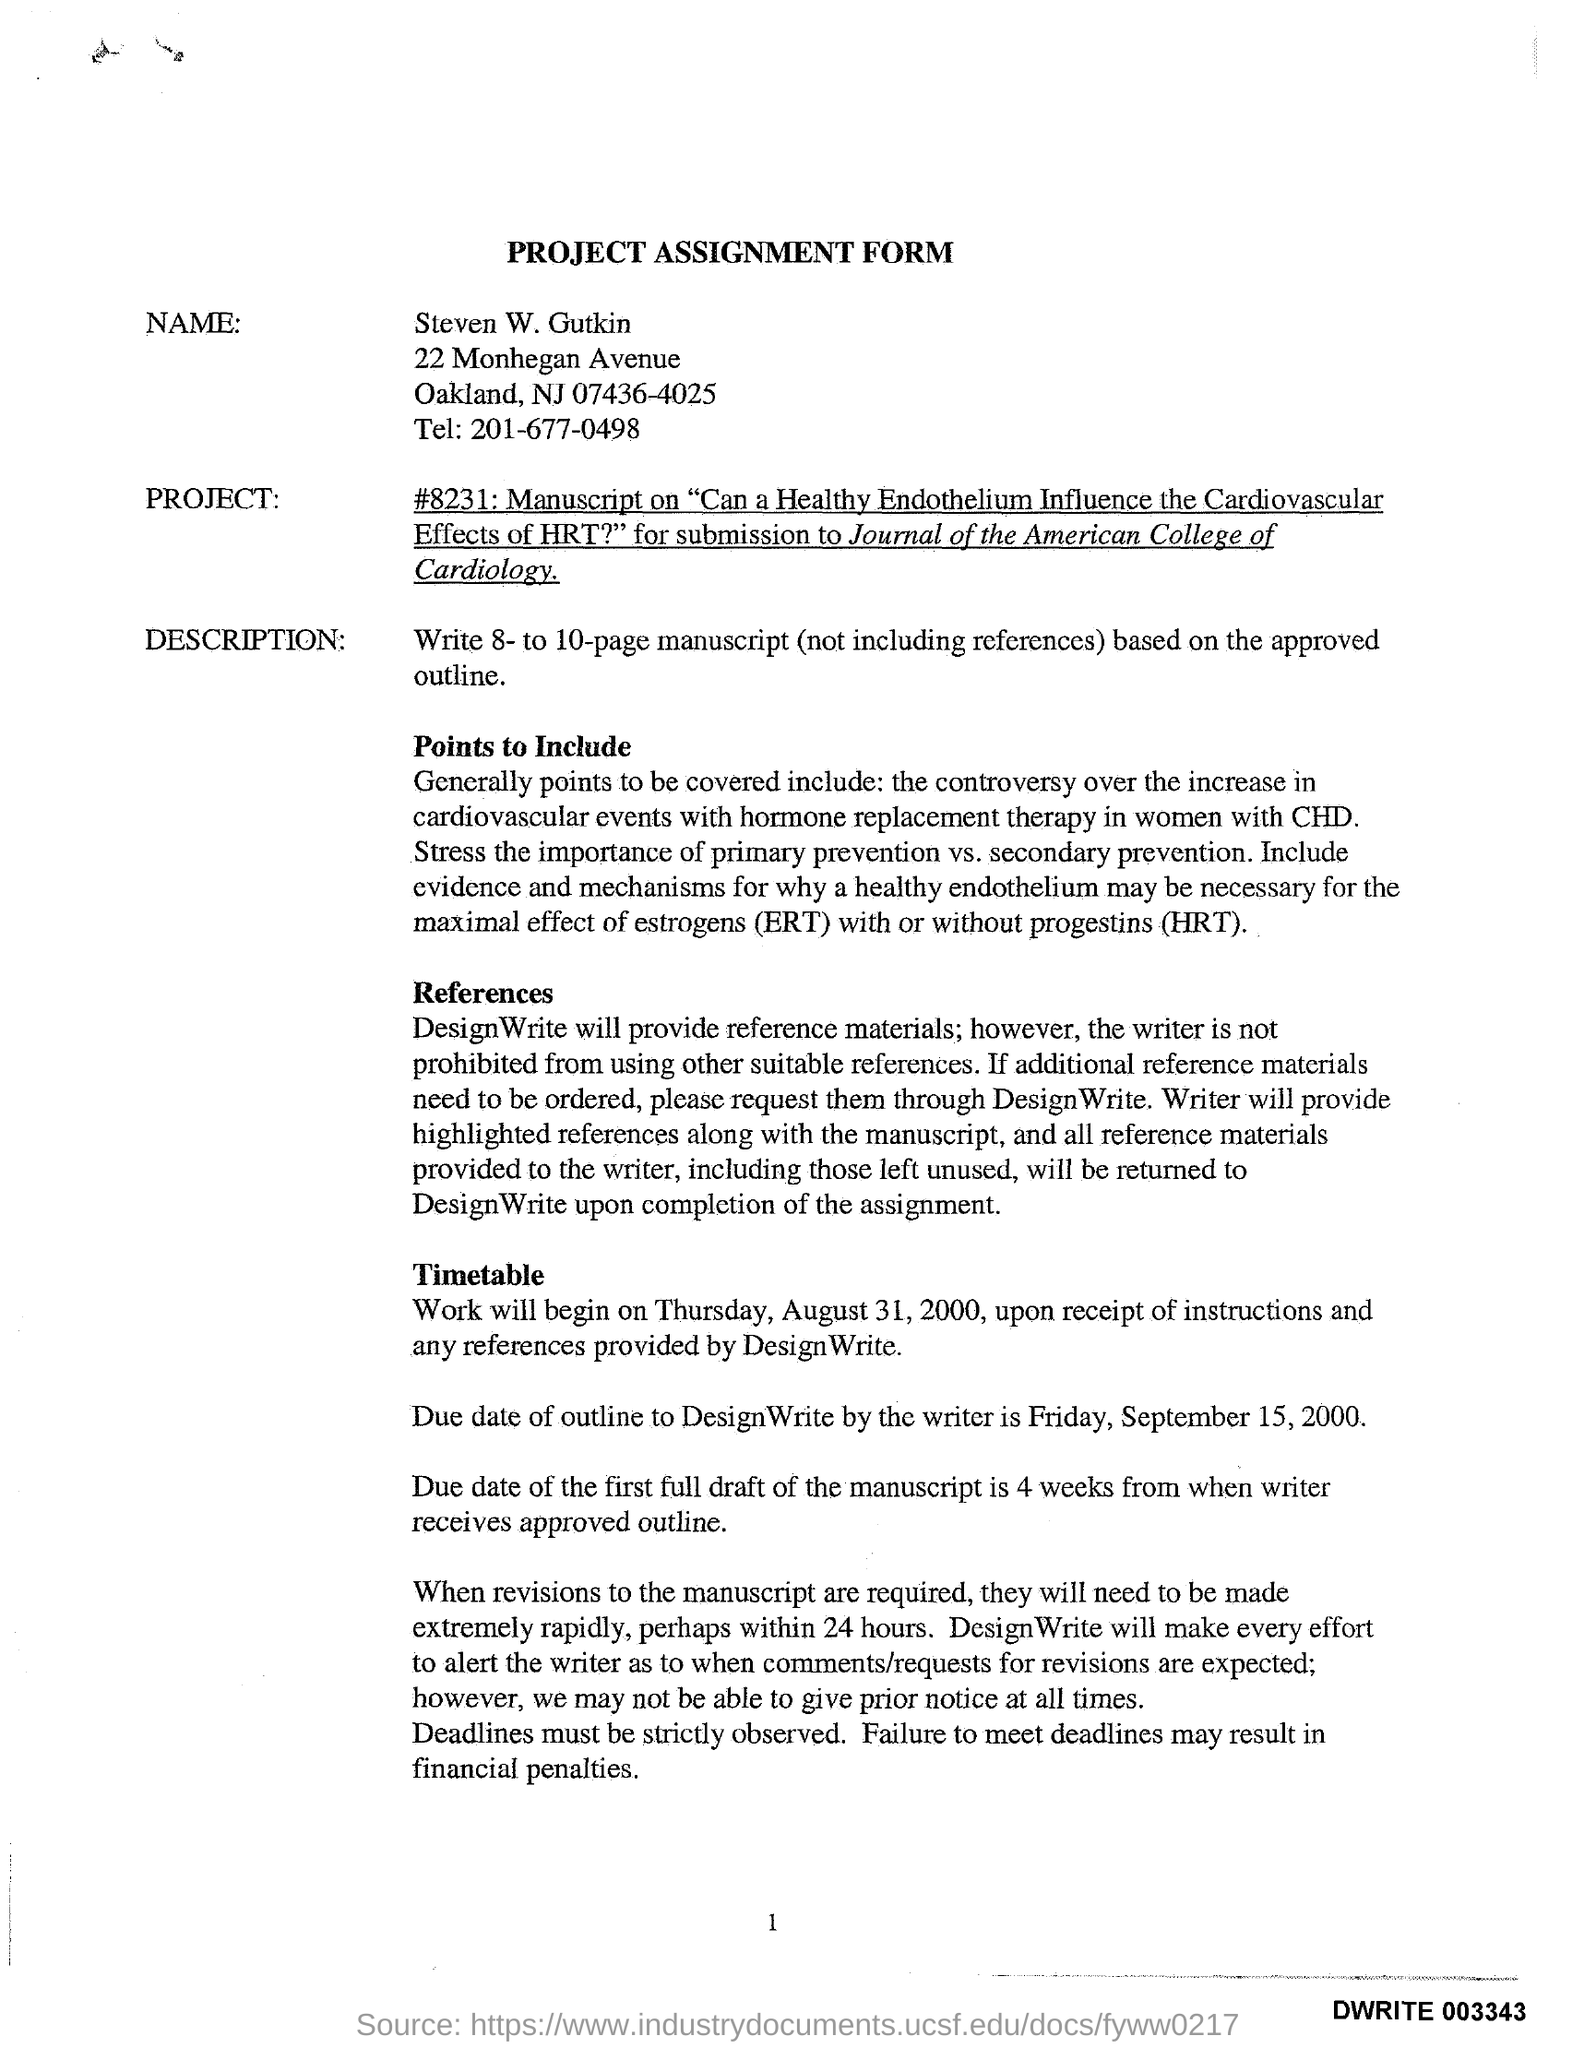List a handful of essential elements in this visual. The title of the form is a project assignment form. The work will commence on Thursday, August 31, 2000. The location of Steven W. Gutkin is at 22 Monhegan Avenue. 